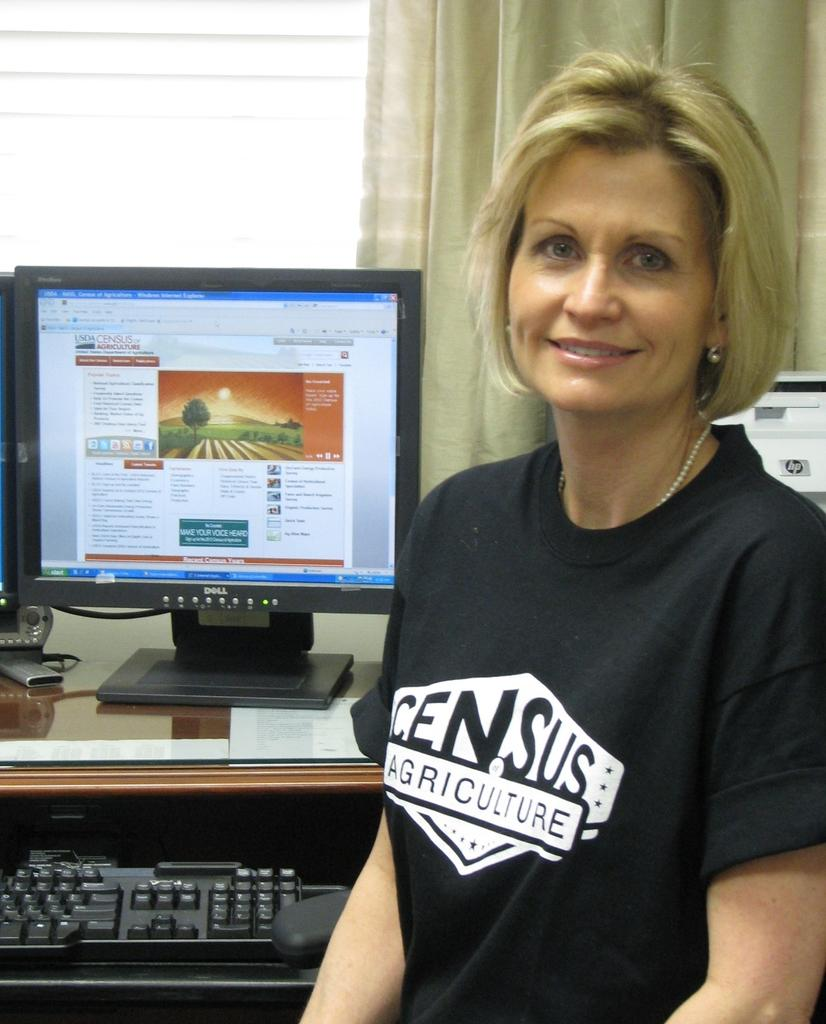<image>
Relay a brief, clear account of the picture shown. Web page USDA Census of Agriculture is pulled up on the Dell desktop. 